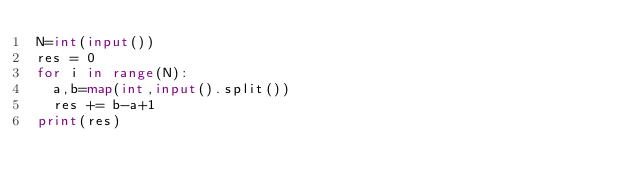<code> <loc_0><loc_0><loc_500><loc_500><_Python_>N=int(input())
res = 0
for i in range(N):
  a,b=map(int,input().split())
  res += b-a+1
print(res)</code> 